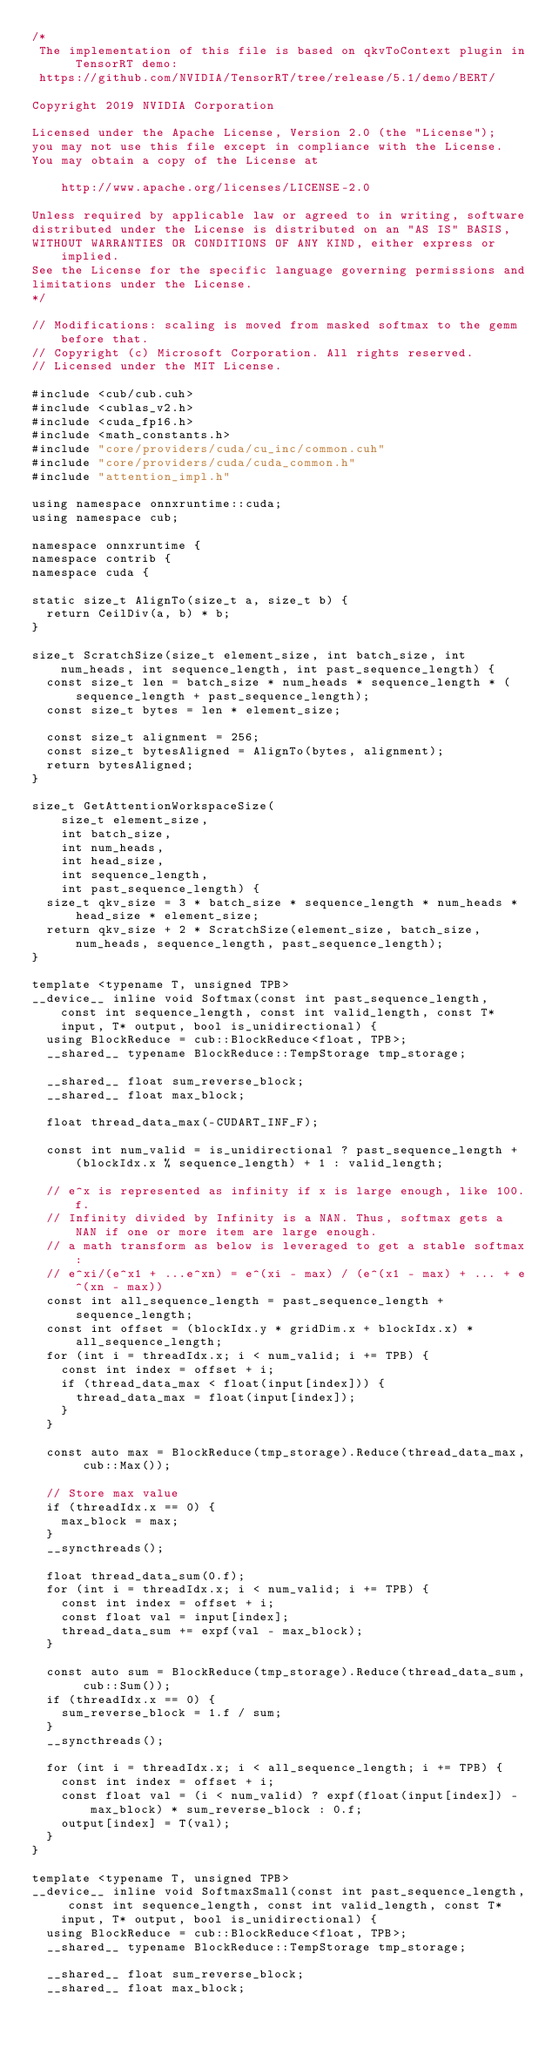<code> <loc_0><loc_0><loc_500><loc_500><_Cuda_>/*
 The implementation of this file is based on qkvToContext plugin in TensorRT demo:
 https://github.com/NVIDIA/TensorRT/tree/release/5.1/demo/BERT/

Copyright 2019 NVIDIA Corporation

Licensed under the Apache License, Version 2.0 (the "License");
you may not use this file except in compliance with the License.
You may obtain a copy of the License at

    http://www.apache.org/licenses/LICENSE-2.0

Unless required by applicable law or agreed to in writing, software
distributed under the License is distributed on an "AS IS" BASIS,
WITHOUT WARRANTIES OR CONDITIONS OF ANY KIND, either express or implied.
See the License for the specific language governing permissions and
limitations under the License.
*/

// Modifications: scaling is moved from masked softmax to the gemm before that.
// Copyright (c) Microsoft Corporation. All rights reserved.
// Licensed under the MIT License.

#include <cub/cub.cuh>
#include <cublas_v2.h>
#include <cuda_fp16.h>
#include <math_constants.h>
#include "core/providers/cuda/cu_inc/common.cuh"
#include "core/providers/cuda/cuda_common.h"
#include "attention_impl.h"

using namespace onnxruntime::cuda;
using namespace cub;

namespace onnxruntime {
namespace contrib {
namespace cuda {

static size_t AlignTo(size_t a, size_t b) {
  return CeilDiv(a, b) * b;
}

size_t ScratchSize(size_t element_size, int batch_size, int num_heads, int sequence_length, int past_sequence_length) {
  const size_t len = batch_size * num_heads * sequence_length * (sequence_length + past_sequence_length);
  const size_t bytes = len * element_size;

  const size_t alignment = 256;
  const size_t bytesAligned = AlignTo(bytes, alignment);
  return bytesAligned;
}

size_t GetAttentionWorkspaceSize(
    size_t element_size,
    int batch_size,
    int num_heads,
    int head_size,
    int sequence_length,
    int past_sequence_length) {
  size_t qkv_size = 3 * batch_size * sequence_length * num_heads * head_size * element_size;
  return qkv_size + 2 * ScratchSize(element_size, batch_size, num_heads, sequence_length, past_sequence_length);
}

template <typename T, unsigned TPB>
__device__ inline void Softmax(const int past_sequence_length, const int sequence_length, const int valid_length, const T* input, T* output, bool is_unidirectional) {
  using BlockReduce = cub::BlockReduce<float, TPB>;
  __shared__ typename BlockReduce::TempStorage tmp_storage;

  __shared__ float sum_reverse_block;
  __shared__ float max_block;

  float thread_data_max(-CUDART_INF_F);

  const int num_valid = is_unidirectional ? past_sequence_length + (blockIdx.x % sequence_length) + 1 : valid_length;

  // e^x is represented as infinity if x is large enough, like 100.f.
  // Infinity divided by Infinity is a NAN. Thus, softmax gets a NAN if one or more item are large enough.
  // a math transform as below is leveraged to get a stable softmax:
  // e^xi/(e^x1 + ...e^xn) = e^(xi - max) / (e^(x1 - max) + ... + e^(xn - max))
  const int all_sequence_length = past_sequence_length + sequence_length;
  const int offset = (blockIdx.y * gridDim.x + blockIdx.x) * all_sequence_length;
  for (int i = threadIdx.x; i < num_valid; i += TPB) {
    const int index = offset + i;
    if (thread_data_max < float(input[index])) {
      thread_data_max = float(input[index]);
    }
  }

  const auto max = BlockReduce(tmp_storage).Reduce(thread_data_max, cub::Max());

  // Store max value
  if (threadIdx.x == 0) {
    max_block = max;
  }
  __syncthreads();

  float thread_data_sum(0.f);
  for (int i = threadIdx.x; i < num_valid; i += TPB) {
    const int index = offset + i;
    const float val = input[index];
    thread_data_sum += expf(val - max_block);
  }

  const auto sum = BlockReduce(tmp_storage).Reduce(thread_data_sum, cub::Sum());
  if (threadIdx.x == 0) {
    sum_reverse_block = 1.f / sum;
  }
  __syncthreads();

  for (int i = threadIdx.x; i < all_sequence_length; i += TPB) {
    const int index = offset + i;
    const float val = (i < num_valid) ? expf(float(input[index]) - max_block) * sum_reverse_block : 0.f;
    output[index] = T(val);
  }
}

template <typename T, unsigned TPB>
__device__ inline void SoftmaxSmall(const int past_sequence_length, const int sequence_length, const int valid_length, const T* input, T* output, bool is_unidirectional) {
  using BlockReduce = cub::BlockReduce<float, TPB>;
  __shared__ typename BlockReduce::TempStorage tmp_storage;

  __shared__ float sum_reverse_block;
  __shared__ float max_block;
</code> 